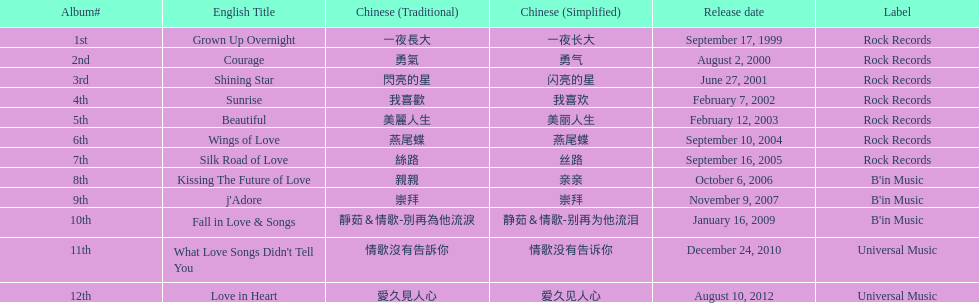What songs were on b'in music or universal music? Kissing The Future of Love, j'Adore, Fall in Love & Songs, What Love Songs Didn't Tell You, Love in Heart. 